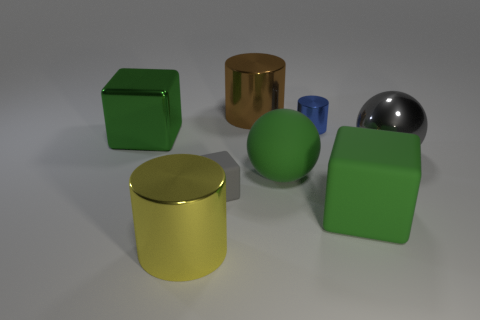What is the shape of the big thing that is both in front of the small gray matte thing and on the right side of the rubber sphere?
Provide a short and direct response. Cube. Is the number of gray balls less than the number of big green rubber things?
Provide a succinct answer. Yes. Is there a big brown matte cylinder?
Ensure brevity in your answer.  No. How many other things are there of the same size as the gray block?
Offer a very short reply. 1. Are the tiny cylinder and the big sphere that is left of the big green matte cube made of the same material?
Offer a terse response. No. Are there the same number of blue cylinders in front of the big gray shiny sphere and large green things that are on the right side of the large brown metallic object?
Make the answer very short. No. What material is the big yellow thing?
Offer a very short reply. Metal. There is a shiny ball that is the same size as the green metallic object; what color is it?
Provide a short and direct response. Gray. Is there a large green block that is in front of the matte cube in front of the tiny matte cube?
Make the answer very short. No. How many cylinders are either yellow objects or green metal objects?
Give a very brief answer. 1. 